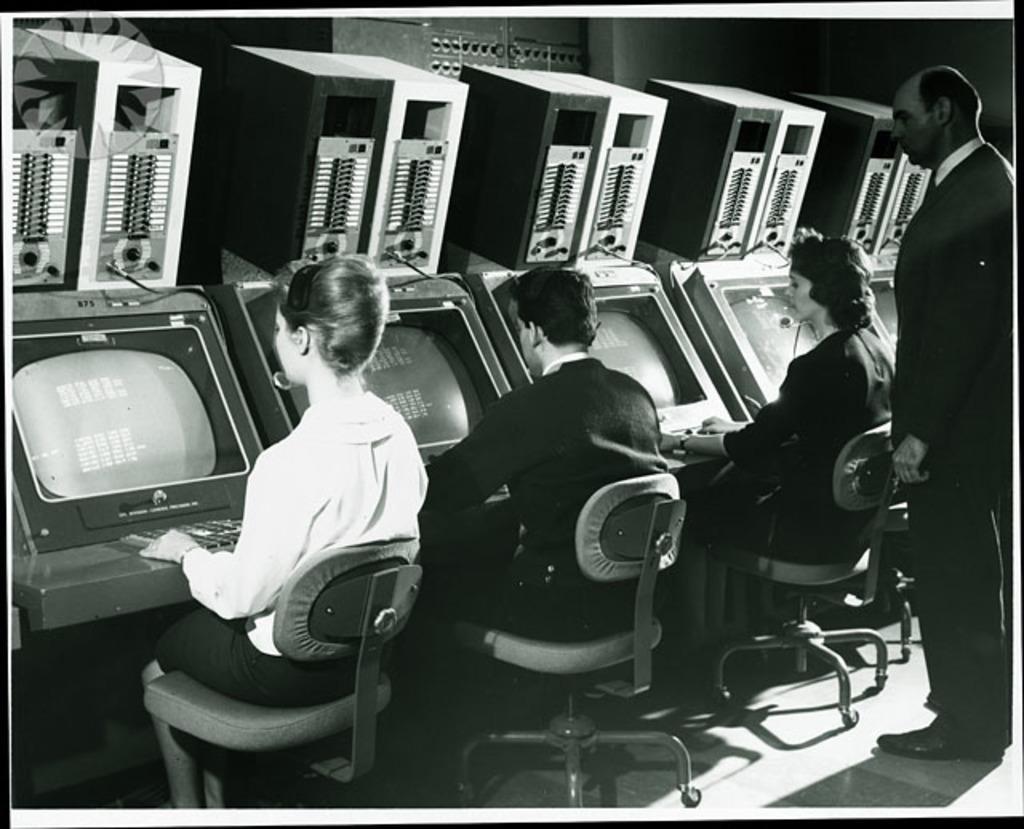Could you give a brief overview of what you see in this image? In this image there are a few people sitting in chairs, in front of them there are monitors with keyboards, above the monitors there are CPU´s, behind them there is a person standing. 